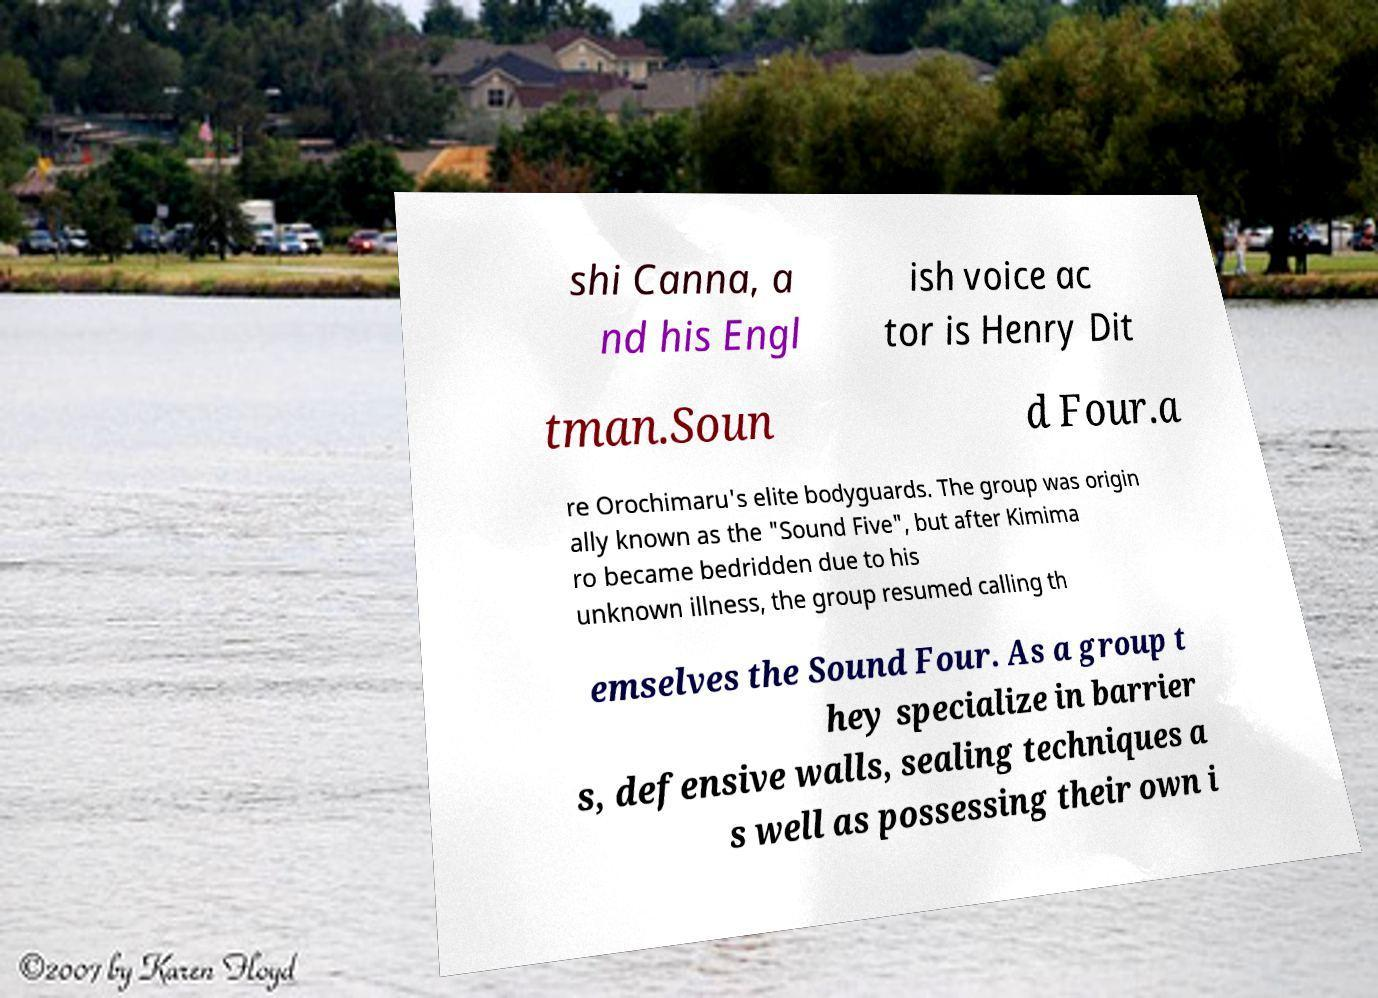Please identify and transcribe the text found in this image. shi Canna, a nd his Engl ish voice ac tor is Henry Dit tman.Soun d Four.a re Orochimaru's elite bodyguards. The group was origin ally known as the "Sound Five", but after Kimima ro became bedridden due to his unknown illness, the group resumed calling th emselves the Sound Four. As a group t hey specialize in barrier s, defensive walls, sealing techniques a s well as possessing their own i 